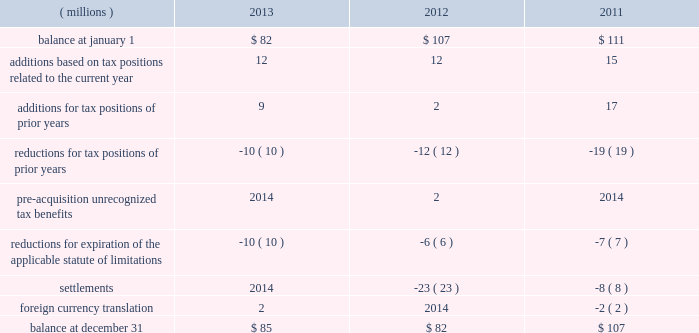52 2013 ppg annual report and form 10-k repatriation of undistributed earnings of non-u.s .
Subsidiaries as of december 31 , 2013 and december 31 , 2012 would have resulted in a u.s .
Tax cost of approximately $ 250 million and $ 110 million , respectively .
The company files federal , state and local income tax returns in numerous domestic and foreign jurisdictions .
In most tax jurisdictions , returns are subject to examination by the relevant tax authorities for a number of years after the returns have been filed .
The company is no longer subject to examinations by tax authorities in any major tax jurisdiction for years before 2006 .
Additionally , the internal revenue service has completed its examination of the company 2019s u.s .
Federal income tax returns filed for years through 2010 .
The examination of the company 2019s u.s .
Federal income tax return for 2011 is currently underway and is expected to be finalized during 2014 .
A reconciliation of the total amounts of unrecognized tax benefits ( excluding interest and penalties ) as of december 31 follows: .
The company expects that any reasonably possible change in the amount of unrecognized tax benefits in the next 12 months would not be significant .
The total amount of unrecognized tax benefits that , if recognized , would affect the effective tax rate was $ 81 million as of december 31 , 2013 .
The company recognizes accrued interest and penalties related to unrecognized tax benefits in income tax expense .
As of december 31 , 2013 , 2012 and 2011 , the company had liabilities for estimated interest and penalties on unrecognized tax benefits of $ 9 million , $ 10 million and $ 15 million , respectively .
The company recognized $ 2 million and $ 5 million of income in 2013 and 2012 , respectively , related to the reduction of estimated interest and penalties .
The company recognized no income or expense for estimated interest and penalties during the year ended december 31 , 2011 .
13 .
Pensions and other postretirement benefits defined benefit plans ppg has defined benefit pension plans that cover certain employees worldwide .
The principal defined benefit pension plans are those in the u.s. , canada , the netherlands and the u.k .
Which , in the aggregate represent approximately 91% ( 91 % ) of the projected benefit obligation at december 31 , 2013 , of which the u.s .
Defined benefit pension plans represent the majority .
Ppg also sponsors welfare benefit plans that provide postretirement medical and life insurance benefits for certain u.s .
And canadian employees and their dependents .
These programs require retiree contributions based on retiree-selected coverage levels for certain retirees and their dependents and provide for sharing of future benefit cost increases between ppg and participants based on management discretion .
The company has the right to modify or terminate certain of these benefit plans in the future .
Salaried and certain hourly employees in the u.s .
Hired on or after october 1 , 2004 , or rehired on or after october 1 , 2012 are not eligible for postretirement medical benefits .
Salaried employees in the u.s .
Hired , rehired or transferred to salaried status on or after january 1 , 2006 , and certain u.s .
Hourly employees hired in 2006 or thereafter are eligible to participate in a defined contribution retirement plan .
These employees are not eligible for defined benefit pension plan benefits .
Plan design changes in january 2011 , the company approved an amendment to one of its u.s .
Defined benefit pension plans that represented about 77% ( 77 % ) of the total u.s .
Projected benefit obligation at december 31 , 2011 .
Depending upon the affected employee's combined age and years of service to ppg , this change resulted in certain employees no longer accruing benefits under this plan as of december 31 , 2011 , while the remaining employees will no longer accrue benefits under this plan as of december 31 , 2020 .
The affected employees will participate in the company 2019s defined contribution retirement plan from the date their benefit under the defined benefit plan is frozen .
The company remeasured the projected benefit obligation of this amended plan , which lowered 2011 pension expense by approximately $ 12 million .
The company made similar changes to certain other u.s .
Defined benefit pension plans in 2011 .
The company recognized a curtailment loss and special termination benefits associated with these plan amendments of $ 5 million in 2011 .
The company plans to continue reviewing and potentially changing other ppg defined benefit plans in the future .
Separation and merger of commodity chemicals business on january 28 , 2013 , ppg completed the separation of its commodity chemicals business and the merger of the subsidiary holding the ppg commodity chemicals business with a subsidiary of georgia gulf , as discussed in note 22 , 201cseparation and merger transaction . 201d ppg transferred the defined benefit pension plan and other postretirement benefit liabilities for the affected employees in the u.s. , canada , and taiwan in the separation resulting in a net partial settlement loss of $ 33 million notes to the consolidated financial statements .
What were the average interest and penalties on unrecognized tax benefits during 2001 through 2013 , in millions ? .? 
Computations: (((9 + 10) + 15) / 3)
Answer: 11.33333. 